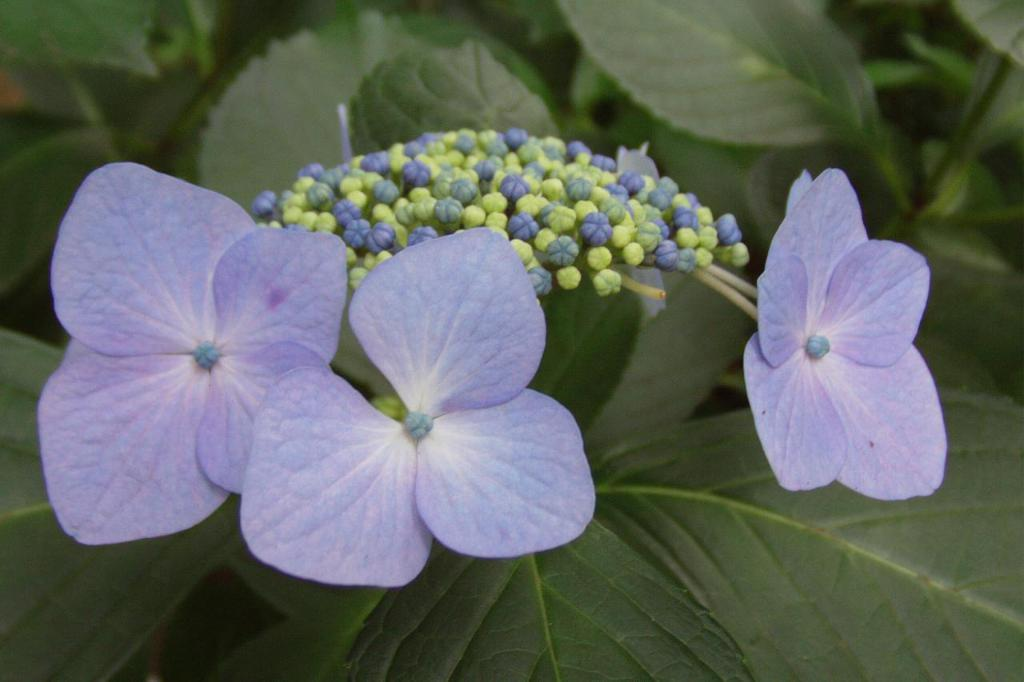What type of plants can be seen in the image? There are flowers in the image. What color are the flowers? The flowers are pale purple in color. Are there any flowers that are not fully bloomed in the image? Yes, there are bud flowers in the image. What else can be seen in the image besides the flowers? Leaves are present in the image. What type of cord is used to hold the flowers in the image? There is no cord present in the image; the flowers are not held by any visible support. 